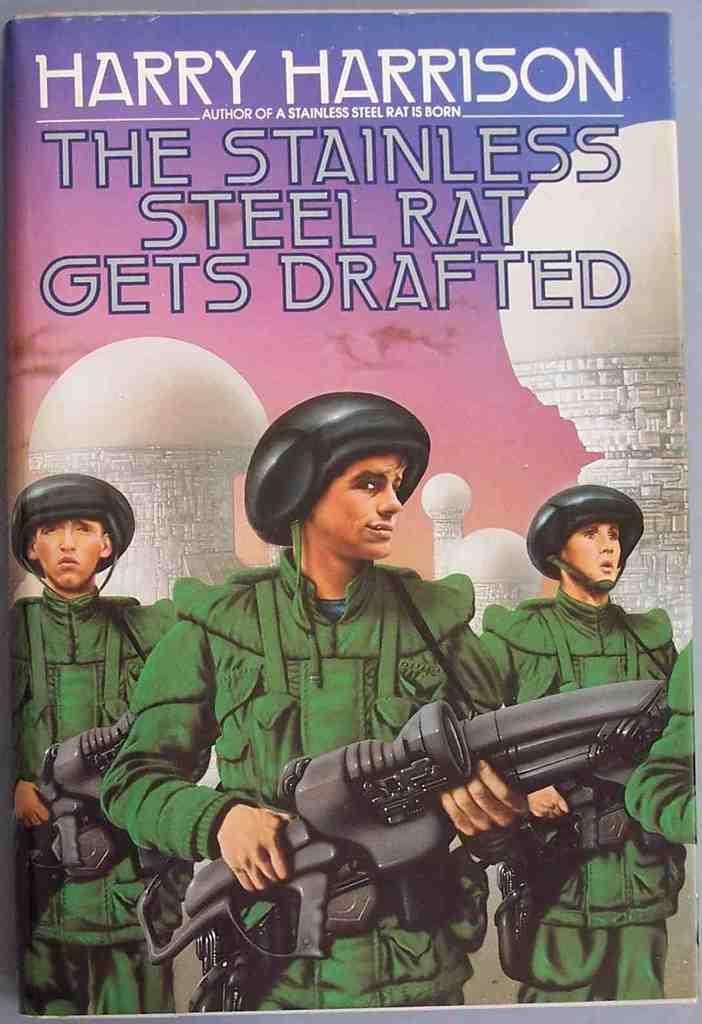Who is this book's writer?
Make the answer very short. Harry harrison. 